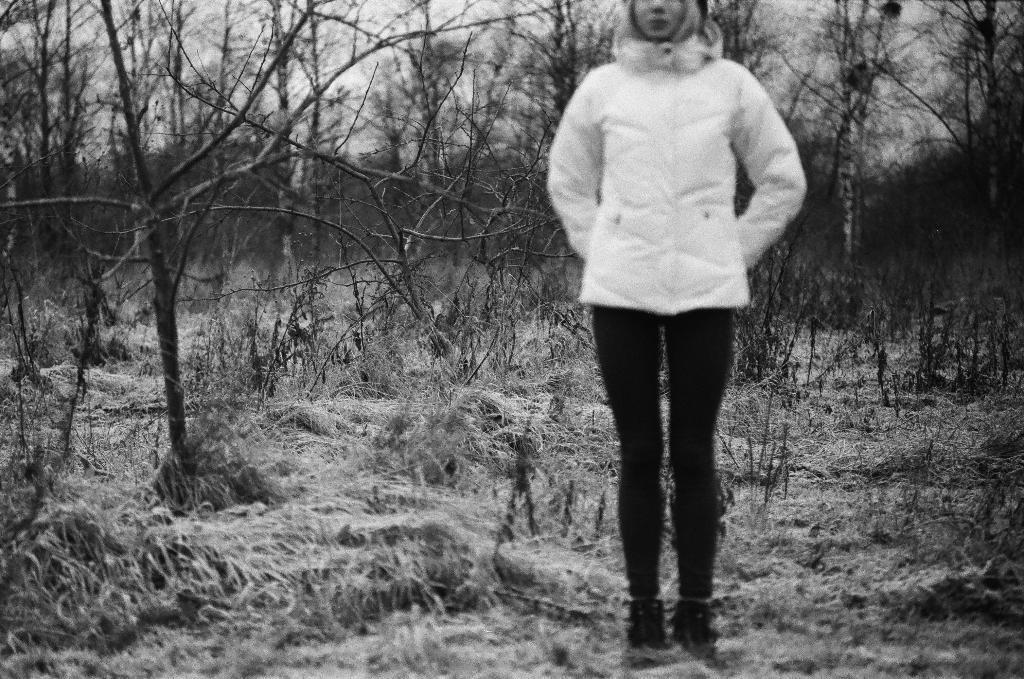Describe this image in one or two sentences. In this image we can see a woman standing on the grass. In the background we can see sky, dried trees and plants. 